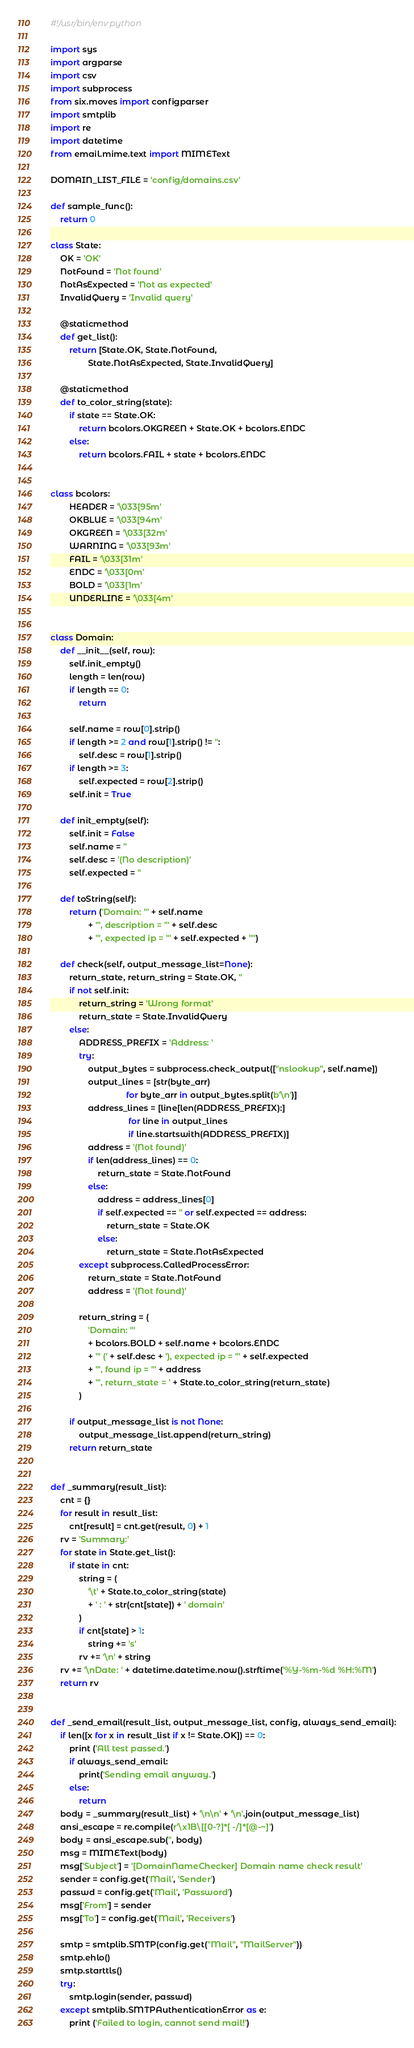<code> <loc_0><loc_0><loc_500><loc_500><_Python_>#!/usr/bin/env python

import sys
import argparse
import csv
import subprocess
from six.moves import configparser
import smtplib
import re
import datetime
from email.mime.text import MIMEText

DOMAIN_LIST_FILE = 'config/domains.csv'

def sample_func():
    return 0

class State:
    OK = 'OK'
    NotFound = 'Not found'
    NotAsExpected = 'Not as expected'
    InvalidQuery = 'Invalid query'

    @staticmethod
    def get_list():
        return [State.OK, State.NotFound,
                State.NotAsExpected, State.InvalidQuery]

    @staticmethod
    def to_color_string(state):
        if state == State.OK:
            return bcolors.OKGREEN + State.OK + bcolors.ENDC
        else:
            return bcolors.FAIL + state + bcolors.ENDC


class bcolors:
        HEADER = '\033[95m'
        OKBLUE = '\033[94m'
        OKGREEN = '\033[32m'
        WARNING = '\033[93m'
        FAIL = '\033[31m'
        ENDC = '\033[0m'
        BOLD = '\033[1m'
        UNDERLINE = '\033[4m'


class Domain:
    def __init__(self, row):
        self.init_empty()
        length = len(row)
        if length == 0:
            return

        self.name = row[0].strip()
        if length >= 2 and row[1].strip() != '':
            self.desc = row[1].strip()
        if length >= 3:
            self.expected = row[2].strip()
        self.init = True

    def init_empty(self):
        self.init = False
        self.name = ''
        self.desc = '(No description)'
        self.expected = ''

    def toString(self):
        return ('Domain: "' + self.name
                + '", description = "' + self.desc
                + '", expected ip = "' + self.expected + '"')

    def check(self, output_message_list=None):
        return_state, return_string = State.OK, ''
        if not self.init:
            return_string = 'Wrong format'
            return_state = State.InvalidQuery
        else:
            ADDRESS_PREFIX = 'Address: '
            try:
                output_bytes = subprocess.check_output(["nslookup", self.name])
                output_lines = [str(byte_arr) 
                                for byte_arr in output_bytes.split(b'\n')]
                address_lines = [line[len(ADDRESS_PREFIX):]
                                 for line in output_lines
                                 if line.startswith(ADDRESS_PREFIX)]
                address = '(Not found)'
                if len(address_lines) == 0:
                    return_state = State.NotFound
                else:
                    address = address_lines[0]
                    if self.expected == '' or self.expected == address:
                        return_state = State.OK
                    else:
                        return_state = State.NotAsExpected
            except subprocess.CalledProcessError:
                return_state = State.NotFound
                address = '(Not found)'

            return_string = (
                'Domain: "'
                + bcolors.BOLD + self.name + bcolors.ENDC
                + '" (' + self.desc + '), expected ip = "' + self.expected
                + '", found ip = "' + address
                + '", return_state = ' + State.to_color_string(return_state)
            )

        if output_message_list is not None:
            output_message_list.append(return_string)
        return return_state


def _summary(result_list):
    cnt = {}
    for result in result_list:
        cnt[result] = cnt.get(result, 0) + 1
    rv = 'Summary:'
    for state in State.get_list():
        if state in cnt:
            string = (
                '\t' + State.to_color_string(state)
                + ' : ' + str(cnt[state]) + ' domain'
            )
            if cnt[state] > 1:
                string += 's'
            rv += '\n' + string
    rv += '\nDate: ' + datetime.datetime.now().strftime('%Y-%m-%d %H:%M')
    return rv


def _send_email(result_list, output_message_list, config, always_send_email):
    if len([x for x in result_list if x != State.OK]) == 0:
        print ('All test passed.')
        if always_send_email:
            print('Sending email anyway.')
        else:
            return
    body = _summary(result_list) + '\n\n' + '\n'.join(output_message_list)
    ansi_escape = re.compile(r'\x1B\[[0-?]*[ -/]*[@-~]')
    body = ansi_escape.sub('', body)
    msg = MIMEText(body)
    msg['Subject'] = '[DomainNameChecker] Domain name check result'
    sender = config.get('Mail', 'Sender')
    passwd = config.get('Mail', 'Password')
    msg['From'] = sender
    msg['To'] = config.get('Mail', 'Receivers')

    smtp = smtplib.SMTP(config.get("Mail", "MailServer"))
    smtp.ehlo()
    smtp.starttls()
    try:
        smtp.login(sender, passwd)
    except smtplib.SMTPAuthenticationError as e:
        print ('Failed to login, cannot send mail!')</code> 